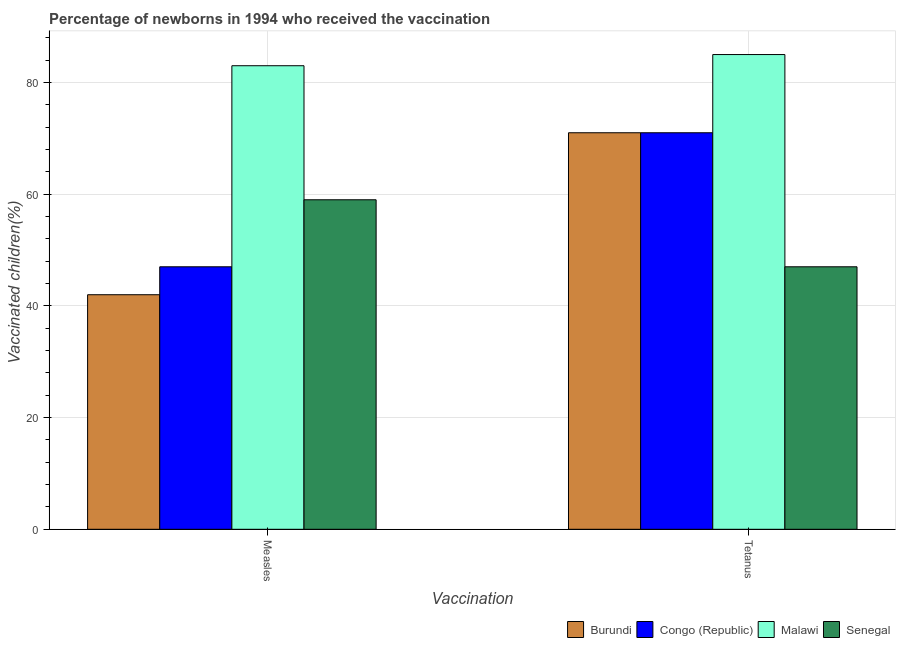How many different coloured bars are there?
Your answer should be compact. 4. How many groups of bars are there?
Ensure brevity in your answer.  2. Are the number of bars per tick equal to the number of legend labels?
Your answer should be compact. Yes. What is the label of the 1st group of bars from the left?
Give a very brief answer. Measles. What is the percentage of newborns who received vaccination for measles in Senegal?
Offer a very short reply. 59. Across all countries, what is the maximum percentage of newborns who received vaccination for tetanus?
Ensure brevity in your answer.  85. Across all countries, what is the minimum percentage of newborns who received vaccination for measles?
Your response must be concise. 42. In which country was the percentage of newborns who received vaccination for measles maximum?
Your response must be concise. Malawi. In which country was the percentage of newborns who received vaccination for measles minimum?
Your response must be concise. Burundi. What is the total percentage of newborns who received vaccination for tetanus in the graph?
Provide a short and direct response. 274. What is the difference between the percentage of newborns who received vaccination for measles in Malawi and that in Burundi?
Make the answer very short. 41. What is the difference between the percentage of newborns who received vaccination for tetanus in Congo (Republic) and the percentage of newborns who received vaccination for measles in Senegal?
Give a very brief answer. 12. What is the average percentage of newborns who received vaccination for measles per country?
Give a very brief answer. 57.75. What is the difference between the percentage of newborns who received vaccination for measles and percentage of newborns who received vaccination for tetanus in Senegal?
Your response must be concise. 12. In how many countries, is the percentage of newborns who received vaccination for tetanus greater than 36 %?
Your response must be concise. 4. What is the ratio of the percentage of newborns who received vaccination for tetanus in Malawi to that in Congo (Republic)?
Your answer should be compact. 1.2. Is the percentage of newborns who received vaccination for measles in Burundi less than that in Congo (Republic)?
Your answer should be compact. Yes. What does the 1st bar from the left in Measles represents?
Provide a succinct answer. Burundi. What does the 1st bar from the right in Tetanus represents?
Provide a short and direct response. Senegal. What is the difference between two consecutive major ticks on the Y-axis?
Keep it short and to the point. 20. Are the values on the major ticks of Y-axis written in scientific E-notation?
Offer a very short reply. No. Does the graph contain any zero values?
Your answer should be compact. No. Does the graph contain grids?
Make the answer very short. Yes. Where does the legend appear in the graph?
Your answer should be compact. Bottom right. How many legend labels are there?
Keep it short and to the point. 4. What is the title of the graph?
Make the answer very short. Percentage of newborns in 1994 who received the vaccination. Does "Angola" appear as one of the legend labels in the graph?
Your answer should be compact. No. What is the label or title of the X-axis?
Give a very brief answer. Vaccination. What is the label or title of the Y-axis?
Your answer should be compact. Vaccinated children(%)
. What is the Vaccinated children(%)
 in Burundi in Measles?
Your answer should be very brief. 42. What is the Vaccinated children(%)
 of Congo (Republic) in Measles?
Offer a very short reply. 47. What is the Vaccinated children(%)
 of Malawi in Measles?
Your answer should be very brief. 83. What is the Vaccinated children(%)
 of Congo (Republic) in Tetanus?
Your answer should be compact. 71. What is the Vaccinated children(%)
 in Malawi in Tetanus?
Ensure brevity in your answer.  85. Across all Vaccination, what is the maximum Vaccinated children(%)
 of Burundi?
Provide a short and direct response. 71. Across all Vaccination, what is the maximum Vaccinated children(%)
 of Congo (Republic)?
Keep it short and to the point. 71. Across all Vaccination, what is the maximum Vaccinated children(%)
 in Senegal?
Your response must be concise. 59. Across all Vaccination, what is the minimum Vaccinated children(%)
 of Congo (Republic)?
Your response must be concise. 47. What is the total Vaccinated children(%)
 in Burundi in the graph?
Your response must be concise. 113. What is the total Vaccinated children(%)
 in Congo (Republic) in the graph?
Offer a terse response. 118. What is the total Vaccinated children(%)
 in Malawi in the graph?
Provide a succinct answer. 168. What is the total Vaccinated children(%)
 in Senegal in the graph?
Provide a short and direct response. 106. What is the difference between the Vaccinated children(%)
 in Malawi in Measles and that in Tetanus?
Keep it short and to the point. -2. What is the difference between the Vaccinated children(%)
 in Burundi in Measles and the Vaccinated children(%)
 in Congo (Republic) in Tetanus?
Make the answer very short. -29. What is the difference between the Vaccinated children(%)
 in Burundi in Measles and the Vaccinated children(%)
 in Malawi in Tetanus?
Your response must be concise. -43. What is the difference between the Vaccinated children(%)
 of Congo (Republic) in Measles and the Vaccinated children(%)
 of Malawi in Tetanus?
Make the answer very short. -38. What is the average Vaccinated children(%)
 of Burundi per Vaccination?
Offer a very short reply. 56.5. What is the average Vaccinated children(%)
 in Congo (Republic) per Vaccination?
Keep it short and to the point. 59. What is the average Vaccinated children(%)
 of Senegal per Vaccination?
Your answer should be very brief. 53. What is the difference between the Vaccinated children(%)
 of Burundi and Vaccinated children(%)
 of Malawi in Measles?
Provide a short and direct response. -41. What is the difference between the Vaccinated children(%)
 of Burundi and Vaccinated children(%)
 of Senegal in Measles?
Keep it short and to the point. -17. What is the difference between the Vaccinated children(%)
 in Congo (Republic) and Vaccinated children(%)
 in Malawi in Measles?
Your answer should be very brief. -36. What is the difference between the Vaccinated children(%)
 of Malawi and Vaccinated children(%)
 of Senegal in Measles?
Provide a short and direct response. 24. What is the difference between the Vaccinated children(%)
 of Burundi and Vaccinated children(%)
 of Malawi in Tetanus?
Offer a terse response. -14. What is the difference between the Vaccinated children(%)
 of Burundi and Vaccinated children(%)
 of Senegal in Tetanus?
Ensure brevity in your answer.  24. What is the difference between the Vaccinated children(%)
 in Congo (Republic) and Vaccinated children(%)
 in Malawi in Tetanus?
Offer a very short reply. -14. What is the difference between the Vaccinated children(%)
 of Congo (Republic) and Vaccinated children(%)
 of Senegal in Tetanus?
Offer a very short reply. 24. What is the difference between the Vaccinated children(%)
 of Malawi and Vaccinated children(%)
 of Senegal in Tetanus?
Your answer should be compact. 38. What is the ratio of the Vaccinated children(%)
 of Burundi in Measles to that in Tetanus?
Ensure brevity in your answer.  0.59. What is the ratio of the Vaccinated children(%)
 in Congo (Republic) in Measles to that in Tetanus?
Keep it short and to the point. 0.66. What is the ratio of the Vaccinated children(%)
 in Malawi in Measles to that in Tetanus?
Give a very brief answer. 0.98. What is the ratio of the Vaccinated children(%)
 of Senegal in Measles to that in Tetanus?
Give a very brief answer. 1.26. What is the difference between the highest and the second highest Vaccinated children(%)
 in Malawi?
Ensure brevity in your answer.  2. What is the difference between the highest and the second highest Vaccinated children(%)
 of Senegal?
Provide a succinct answer. 12. What is the difference between the highest and the lowest Vaccinated children(%)
 in Burundi?
Your answer should be very brief. 29. What is the difference between the highest and the lowest Vaccinated children(%)
 of Congo (Republic)?
Offer a very short reply. 24. What is the difference between the highest and the lowest Vaccinated children(%)
 of Malawi?
Offer a terse response. 2. 